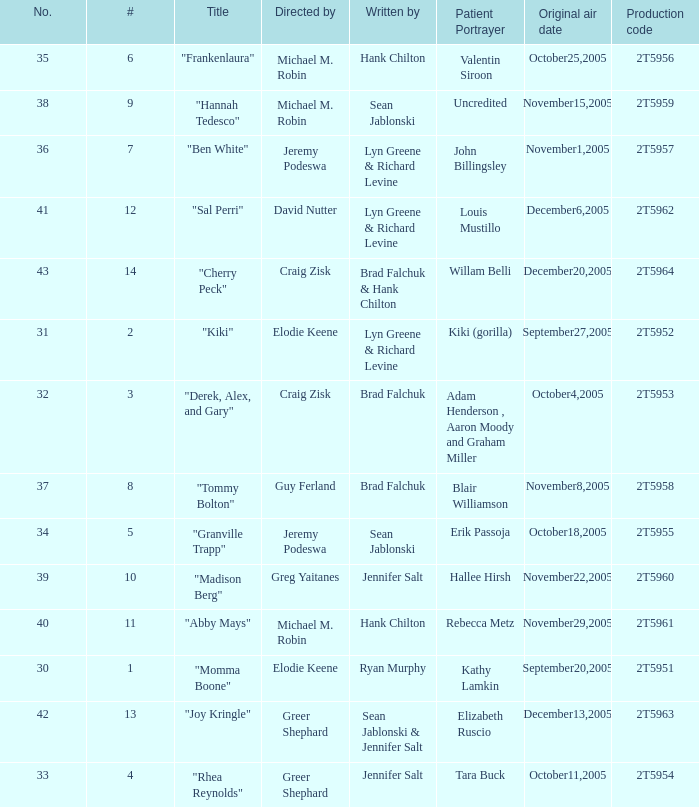Who were the writers for the episode titled "Ben White"? Lyn Greene & Richard Levine. 